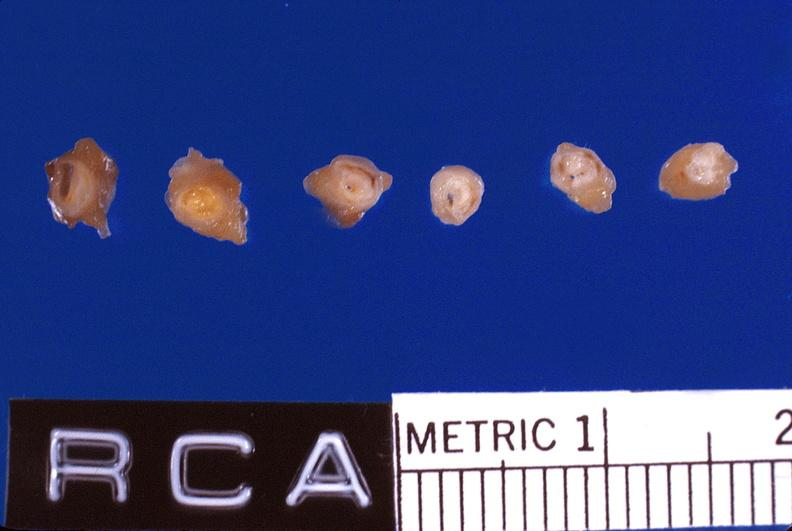s cardiovascular present?
Answer the question using a single word or phrase. Yes 